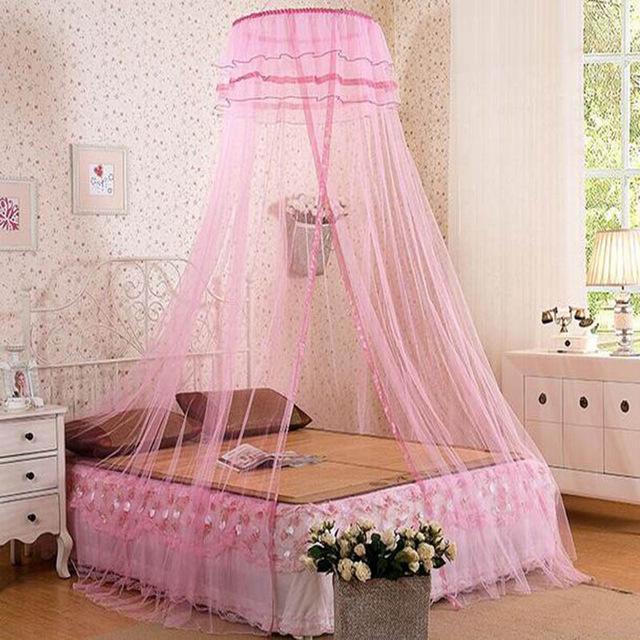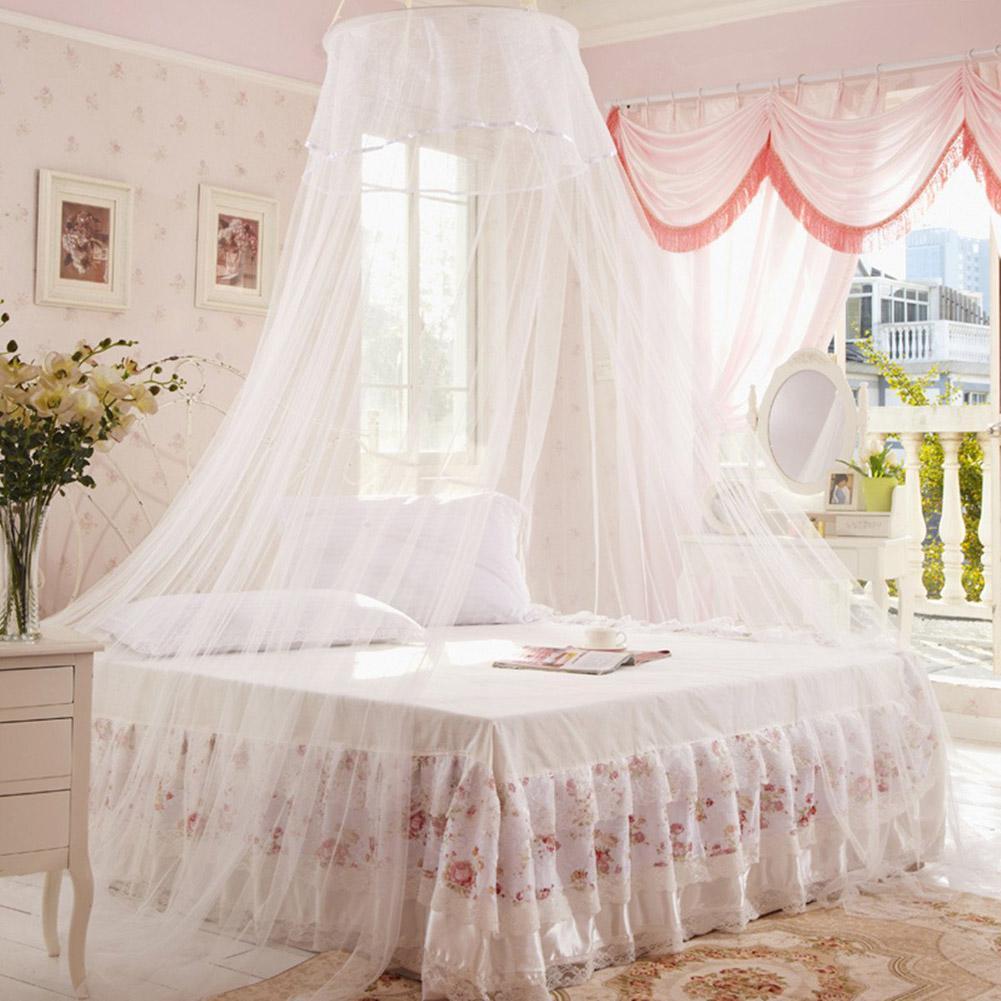The first image is the image on the left, the second image is the image on the right. For the images displayed, is the sentence "The left and right image contains a total of two pink canopies." factually correct? Answer yes or no. No. The first image is the image on the left, the second image is the image on the right. Given the left and right images, does the statement "All the bed nets are pink." hold true? Answer yes or no. No. 